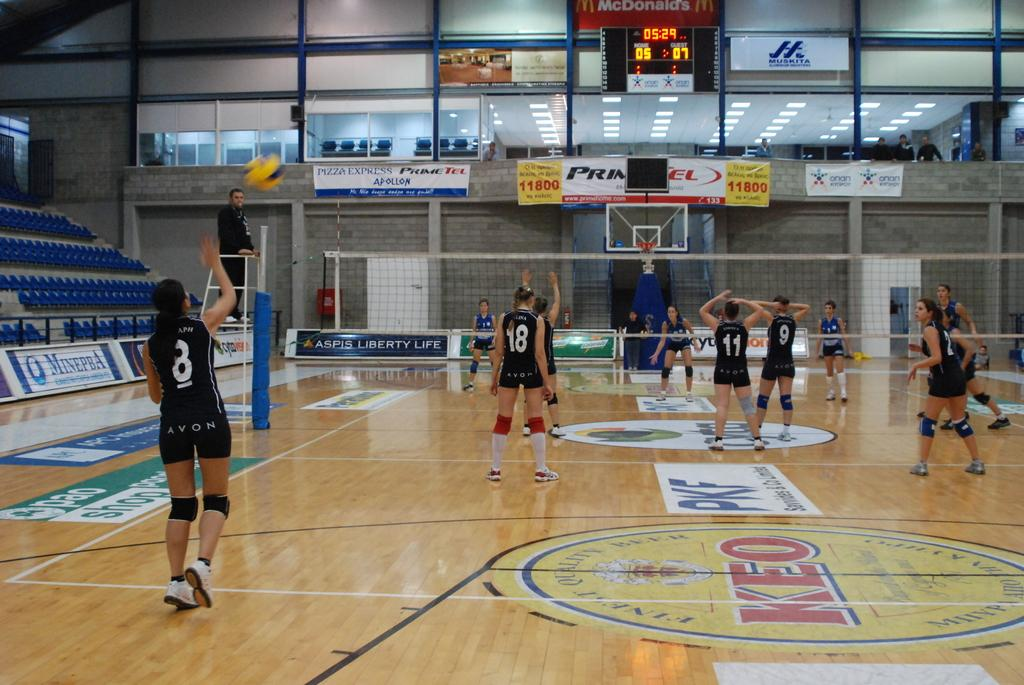<image>
Provide a brief description of the given image. A group of women with shorts that say Avon on the back play volleyball. 